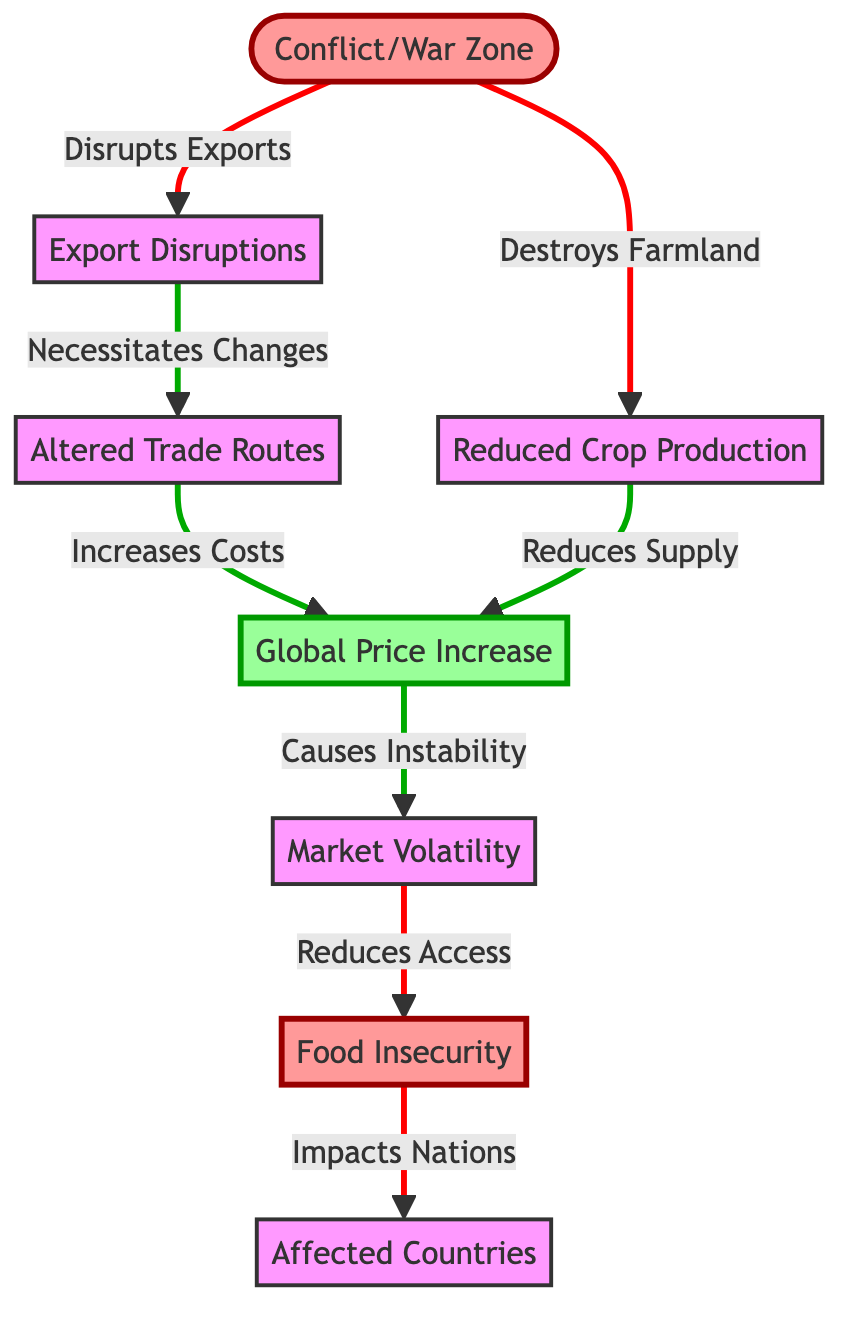What node directly follows "Export Disruptions"? In the diagram, "Export Disruptions" leads directly to "Altered Trade Routes", indicating a direct relationship between these nodes.
Answer: Altered Trade Routes How many total nodes are present in the diagram? By counting all the distinct elements in the diagram including the impact and effect nodes, there are a total of 8 nodes.
Answer: 8 What effect does "Reduced Crop Production" have on "Global Price Increase"? The diagram shows "Reduced Crop Production" leading to "Global Price Increase", indicating that it directly reduces the supply of food, causing the price to increase.
Answer: Reduces Supply Which node ultimately impacts "Affected Countries"? "Food Insecurity" is shown in the diagram to impact "Affected Countries", indicating that issues with food security due to price increases and market volatility spread effects to nations involved.
Answer: Food Insecurity What is the primary action taken by "Conflict/War Zone"? The diagram indicates that "Conflict/War Zone" destroys farmland, which is a crucial action that initiates the chain of effects throughout the diagram.
Answer: Destroys Farmland What happens to “Global Price Increase” as a result of “Market Volatility”? The flowchart indicates that "Global Price Increase" causes instability, which stems from the fluctuations and uncertainties arising from market volatility.
Answer: Causes Instability How does "Altered Trade Routes" impact costs? “Altered Trade Routes” leads to “Global Price Increase” by increasing transportation and logistical costs, reflecting a monetary impact related to the changes in trading patterns.
Answer: Increases Costs What node connects “Reduced Crop Production” and “Market Volatility”? The relationship from "Reduced Crop Production" indicates that it affects "Global Price Increase", which in turn influences "Market Volatility" through instability in prices, creating a link back into the chain.
Answer: Global Price Increase 